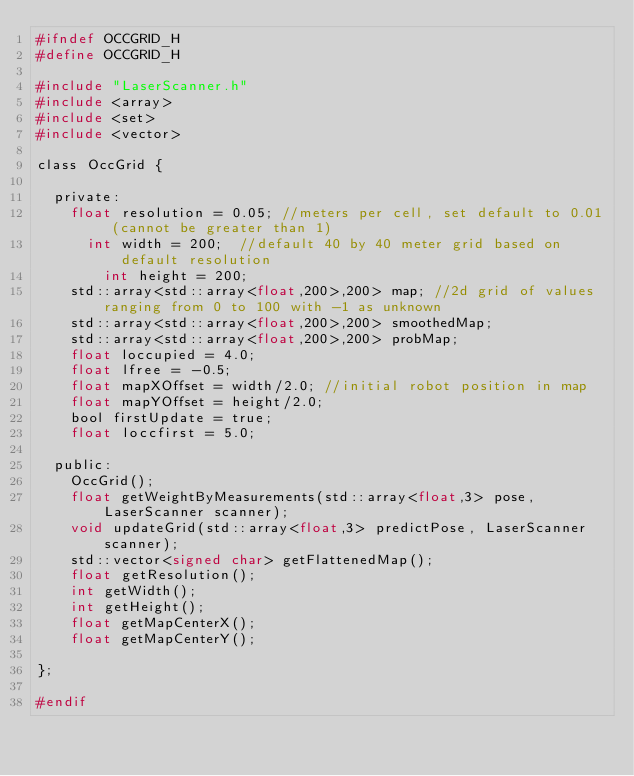<code> <loc_0><loc_0><loc_500><loc_500><_C_>#ifndef OCCGRID_H
#define OCCGRID_H

#include "LaserScanner.h"
#include <array>
#include <set>
#include <vector>

class OccGrid {

  private:
    float resolution = 0.05; //meters per cell, set default to 0.01 (cannot be greater than 1)
	  int width = 200;  //default 40 by 40 meter grid based on default resolution
		int height = 200;
    std::array<std::array<float,200>,200> map; //2d grid of values ranging from 0 to 100 with -1 as unknown
    std::array<std::array<float,200>,200> smoothedMap;
    std::array<std::array<float,200>,200> probMap;
    float loccupied = 4.0;
    float lfree = -0.5;
    float mapXOffset = width/2.0; //initial robot position in map
    float mapYOffset = height/2.0;
    bool firstUpdate = true;
    float loccfirst = 5.0;

  public:
    OccGrid();
    float getWeightByMeasurements(std::array<float,3> pose, LaserScanner scanner);
    void updateGrid(std::array<float,3> predictPose, LaserScanner scanner);
    std::vector<signed char> getFlattenedMap();
    float getResolution();
    int getWidth();
    int getHeight();
    float getMapCenterX();
    float getMapCenterY();

};

#endif
</code> 